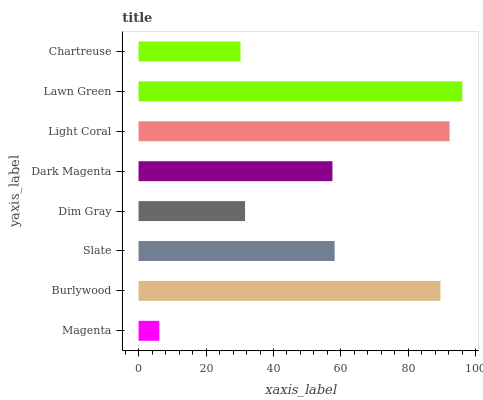Is Magenta the minimum?
Answer yes or no. Yes. Is Lawn Green the maximum?
Answer yes or no. Yes. Is Burlywood the minimum?
Answer yes or no. No. Is Burlywood the maximum?
Answer yes or no. No. Is Burlywood greater than Magenta?
Answer yes or no. Yes. Is Magenta less than Burlywood?
Answer yes or no. Yes. Is Magenta greater than Burlywood?
Answer yes or no. No. Is Burlywood less than Magenta?
Answer yes or no. No. Is Slate the high median?
Answer yes or no. Yes. Is Dark Magenta the low median?
Answer yes or no. Yes. Is Dark Magenta the high median?
Answer yes or no. No. Is Chartreuse the low median?
Answer yes or no. No. 